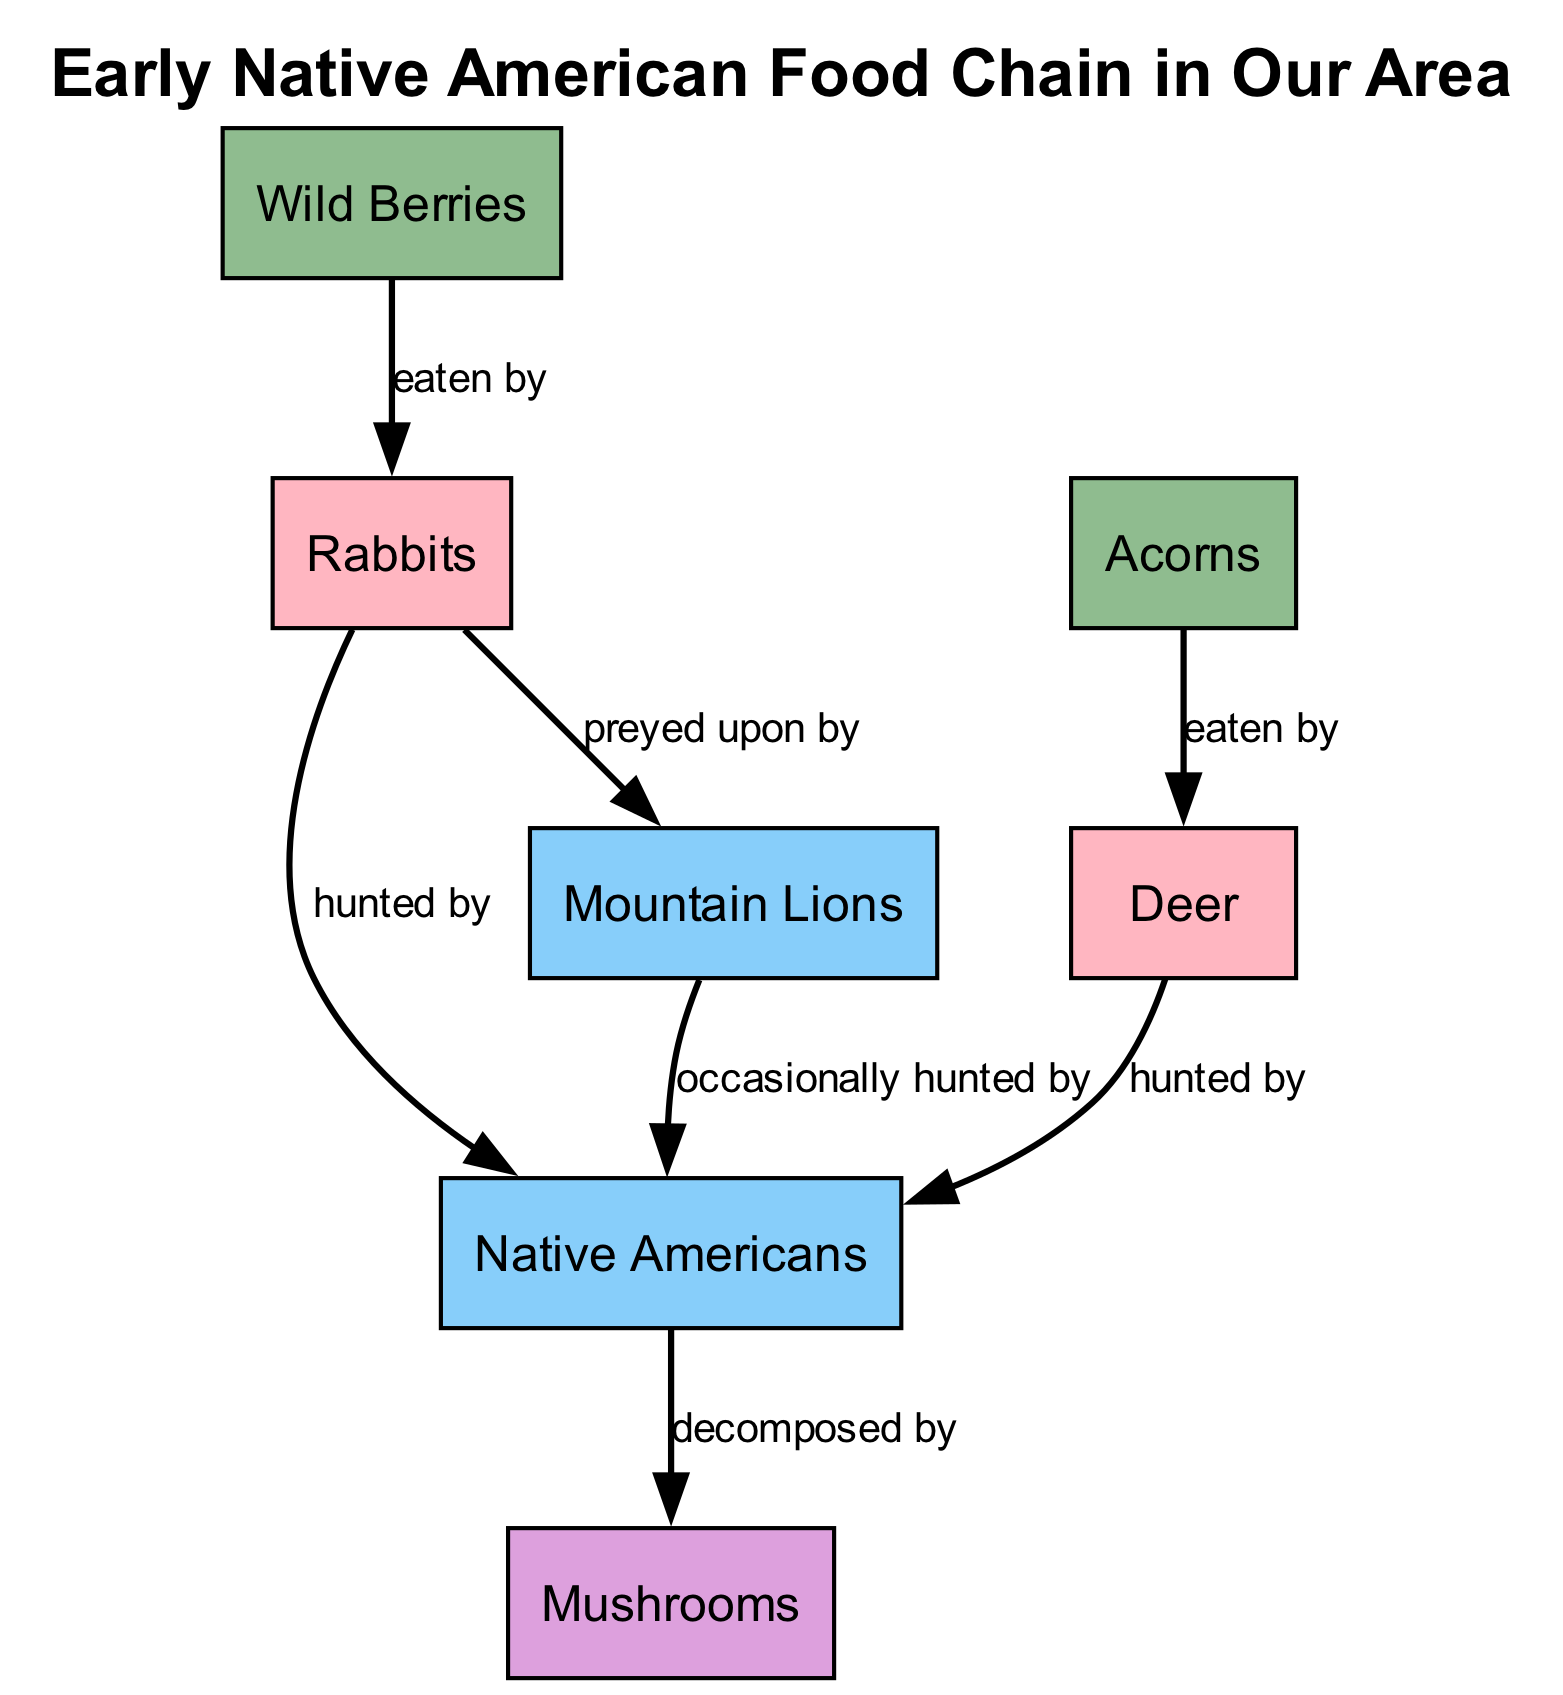What are the primary consumers in this food chain? The diagram shows two primary consumers: Deer and Rabbits. By identifying the nodes labeled as "primary consumer" in the diagram, we can see these two specific elements represented.
Answer: Deer, Rabbits How many producers are there in the diagram? The diagram lists two producers: Wild Berries and Acorns. Counting the nodes specifically marked as "producer", we find two total instances.
Answer: 2 Who is the secondary consumer that hunts Rabbits? The diagram indicates that Native Americans are the secondary consumer that hunts Rabbits. It is specified by the directed edge labeled "hunted by".
Answer: Native Americans What do mushrooms represent in the food chain? Mushrooms serve as the decomposer in the food chain. The diagram shows this by labeling the mushroom node as "decomposer".
Answer: Decomposer Which producer is eaten by Rabbits? Rabbits eat Wild Berries, as indicated by the connection labeled "eaten by" between the two nodes. This is a direct link in the food chain that identifies the relationship.
Answer: Wild Berries How are Mountain Lions related to Native Americans in this food chain? Mountain Lions are occasionally hunted by Native Americans, as shown by the connection labeled "occasionally hunted by". This implies a predatory and hunting relationship in the food chain.
Answer: Occasionally hunted by What role do Deer play in this food chain? Deer are classified as primary consumers, specifically being hunted by Native Americans, as indicated by the connections in the diagram. They serve as a source of food for the humans in this food chain.
Answer: Primary consumer What is the relationship between Rabbits and Mountain Lions? The relationship signifies that Rabbits are preyed upon by Mountain Lions, as indicated by the connection labeled "preyed upon by". This expresses the predatory dynamic in the food chain.
Answer: Preyed upon by How many connections are there in the food chain? The diagram illustrates six distinct connections among the elements, indicating the relationships and flow of energy in the food chain. By counting all the edges, we arrive at this number.
Answer: 6 